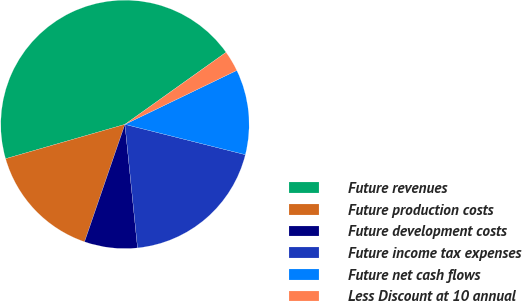Convert chart to OTSL. <chart><loc_0><loc_0><loc_500><loc_500><pie_chart><fcel>Future revenues<fcel>Future production costs<fcel>Future development costs<fcel>Future income tax expenses<fcel>Future net cash flows<fcel>Less Discount at 10 annual<nl><fcel>44.61%<fcel>15.27%<fcel>6.89%<fcel>19.46%<fcel>11.08%<fcel>2.7%<nl></chart> 